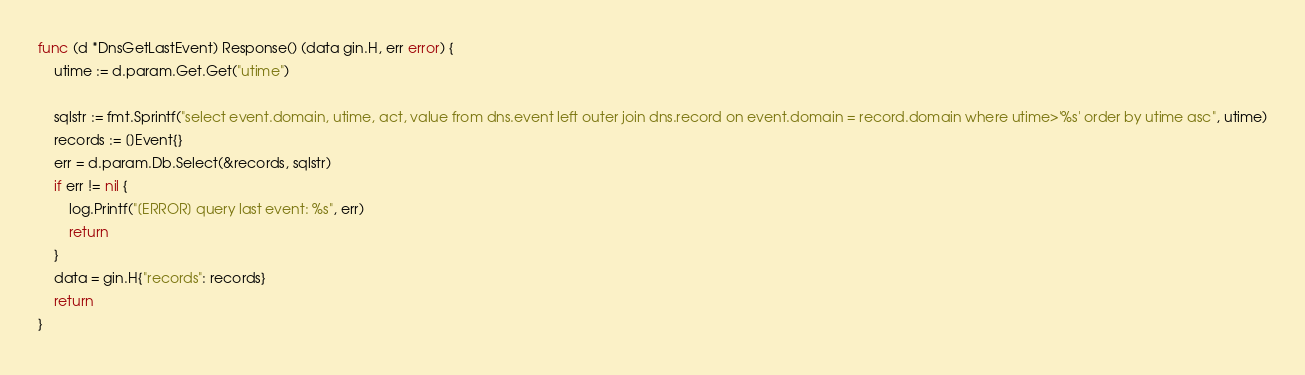<code> <loc_0><loc_0><loc_500><loc_500><_Go_>func (d *DnsGetLastEvent) Response() (data gin.H, err error) {
	utime := d.param.Get.Get("utime")

	sqlstr := fmt.Sprintf("select event.domain, utime, act, value from dns.event left outer join dns.record on event.domain = record.domain where utime>'%s' order by utime asc", utime)
	records := []Event{}
	err = d.param.Db.Select(&records, sqlstr)
	if err != nil {
		log.Printf("[ERROR] query last event: %s", err)
		return
	}
	data = gin.H{"records": records}
	return
}
</code> 